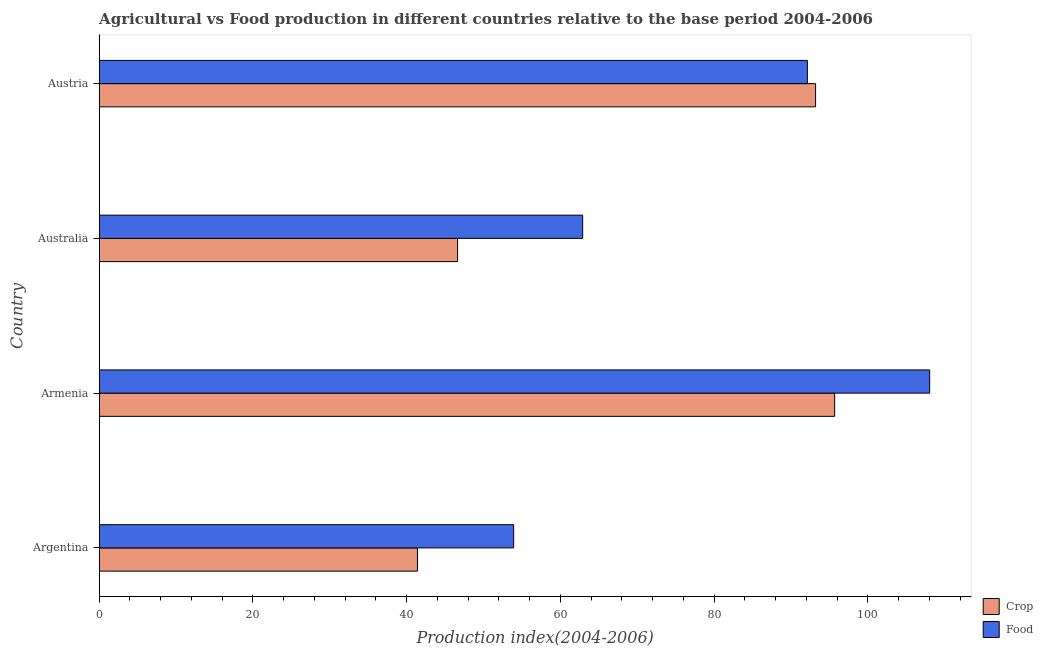How many different coloured bars are there?
Make the answer very short. 2. How many groups of bars are there?
Your answer should be compact. 4. Are the number of bars on each tick of the Y-axis equal?
Your response must be concise. Yes. How many bars are there on the 4th tick from the top?
Give a very brief answer. 2. How many bars are there on the 4th tick from the bottom?
Your answer should be compact. 2. What is the label of the 4th group of bars from the top?
Provide a short and direct response. Argentina. What is the food production index in Argentina?
Your answer should be very brief. 53.91. Across all countries, what is the maximum food production index?
Ensure brevity in your answer.  108.03. Across all countries, what is the minimum food production index?
Your response must be concise. 53.91. In which country was the food production index maximum?
Keep it short and to the point. Armenia. In which country was the crop production index minimum?
Your answer should be very brief. Argentina. What is the total crop production index in the graph?
Offer a terse response. 276.88. What is the difference between the crop production index in Australia and that in Austria?
Give a very brief answer. -46.57. What is the difference between the food production index in Australia and the crop production index in Austria?
Provide a succinct answer. -30.3. What is the average food production index per country?
Offer a terse response. 79.24. What is the difference between the crop production index and food production index in Argentina?
Offer a terse response. -12.51. In how many countries, is the food production index greater than 4 ?
Give a very brief answer. 4. Is the food production index in Armenia less than that in Austria?
Your answer should be compact. No. What is the difference between the highest and the second highest crop production index?
Provide a short and direct response. 2.48. What is the difference between the highest and the lowest food production index?
Provide a succinct answer. 54.12. Is the sum of the crop production index in Armenia and Australia greater than the maximum food production index across all countries?
Your response must be concise. Yes. What does the 2nd bar from the top in Armenia represents?
Provide a short and direct response. Crop. What does the 1st bar from the bottom in Australia represents?
Ensure brevity in your answer.  Crop. Are all the bars in the graph horizontal?
Your answer should be very brief. Yes. How many countries are there in the graph?
Provide a short and direct response. 4. What is the difference between two consecutive major ticks on the X-axis?
Make the answer very short. 20. Where does the legend appear in the graph?
Offer a terse response. Bottom right. How many legend labels are there?
Give a very brief answer. 2. What is the title of the graph?
Give a very brief answer. Agricultural vs Food production in different countries relative to the base period 2004-2006. Does "Unregistered firms" appear as one of the legend labels in the graph?
Offer a terse response. No. What is the label or title of the X-axis?
Make the answer very short. Production index(2004-2006). What is the label or title of the Y-axis?
Provide a short and direct response. Country. What is the Production index(2004-2006) of Crop in Argentina?
Make the answer very short. 41.4. What is the Production index(2004-2006) of Food in Argentina?
Ensure brevity in your answer.  53.91. What is the Production index(2004-2006) in Crop in Armenia?
Keep it short and to the point. 95.67. What is the Production index(2004-2006) in Food in Armenia?
Offer a terse response. 108.03. What is the Production index(2004-2006) of Crop in Australia?
Offer a very short reply. 46.62. What is the Production index(2004-2006) of Food in Australia?
Provide a short and direct response. 62.89. What is the Production index(2004-2006) in Crop in Austria?
Your response must be concise. 93.19. What is the Production index(2004-2006) in Food in Austria?
Provide a short and direct response. 92.12. Across all countries, what is the maximum Production index(2004-2006) of Crop?
Make the answer very short. 95.67. Across all countries, what is the maximum Production index(2004-2006) in Food?
Give a very brief answer. 108.03. Across all countries, what is the minimum Production index(2004-2006) of Crop?
Your response must be concise. 41.4. Across all countries, what is the minimum Production index(2004-2006) in Food?
Make the answer very short. 53.91. What is the total Production index(2004-2006) of Crop in the graph?
Give a very brief answer. 276.88. What is the total Production index(2004-2006) of Food in the graph?
Offer a terse response. 316.95. What is the difference between the Production index(2004-2006) of Crop in Argentina and that in Armenia?
Offer a terse response. -54.27. What is the difference between the Production index(2004-2006) of Food in Argentina and that in Armenia?
Provide a short and direct response. -54.12. What is the difference between the Production index(2004-2006) of Crop in Argentina and that in Australia?
Ensure brevity in your answer.  -5.22. What is the difference between the Production index(2004-2006) of Food in Argentina and that in Australia?
Provide a short and direct response. -8.98. What is the difference between the Production index(2004-2006) in Crop in Argentina and that in Austria?
Provide a succinct answer. -51.79. What is the difference between the Production index(2004-2006) of Food in Argentina and that in Austria?
Provide a succinct answer. -38.21. What is the difference between the Production index(2004-2006) of Crop in Armenia and that in Australia?
Offer a terse response. 49.05. What is the difference between the Production index(2004-2006) in Food in Armenia and that in Australia?
Your answer should be very brief. 45.14. What is the difference between the Production index(2004-2006) of Crop in Armenia and that in Austria?
Provide a short and direct response. 2.48. What is the difference between the Production index(2004-2006) of Food in Armenia and that in Austria?
Provide a succinct answer. 15.91. What is the difference between the Production index(2004-2006) in Crop in Australia and that in Austria?
Offer a very short reply. -46.57. What is the difference between the Production index(2004-2006) in Food in Australia and that in Austria?
Ensure brevity in your answer.  -29.23. What is the difference between the Production index(2004-2006) in Crop in Argentina and the Production index(2004-2006) in Food in Armenia?
Offer a terse response. -66.63. What is the difference between the Production index(2004-2006) of Crop in Argentina and the Production index(2004-2006) of Food in Australia?
Keep it short and to the point. -21.49. What is the difference between the Production index(2004-2006) in Crop in Argentina and the Production index(2004-2006) in Food in Austria?
Offer a very short reply. -50.72. What is the difference between the Production index(2004-2006) in Crop in Armenia and the Production index(2004-2006) in Food in Australia?
Your answer should be compact. 32.78. What is the difference between the Production index(2004-2006) of Crop in Armenia and the Production index(2004-2006) of Food in Austria?
Keep it short and to the point. 3.55. What is the difference between the Production index(2004-2006) in Crop in Australia and the Production index(2004-2006) in Food in Austria?
Your response must be concise. -45.5. What is the average Production index(2004-2006) of Crop per country?
Provide a succinct answer. 69.22. What is the average Production index(2004-2006) of Food per country?
Offer a very short reply. 79.24. What is the difference between the Production index(2004-2006) of Crop and Production index(2004-2006) of Food in Argentina?
Provide a succinct answer. -12.51. What is the difference between the Production index(2004-2006) of Crop and Production index(2004-2006) of Food in Armenia?
Your answer should be very brief. -12.36. What is the difference between the Production index(2004-2006) of Crop and Production index(2004-2006) of Food in Australia?
Your response must be concise. -16.27. What is the difference between the Production index(2004-2006) in Crop and Production index(2004-2006) in Food in Austria?
Your answer should be compact. 1.07. What is the ratio of the Production index(2004-2006) in Crop in Argentina to that in Armenia?
Your answer should be compact. 0.43. What is the ratio of the Production index(2004-2006) of Food in Argentina to that in Armenia?
Provide a short and direct response. 0.5. What is the ratio of the Production index(2004-2006) of Crop in Argentina to that in Australia?
Make the answer very short. 0.89. What is the ratio of the Production index(2004-2006) in Food in Argentina to that in Australia?
Your answer should be compact. 0.86. What is the ratio of the Production index(2004-2006) of Crop in Argentina to that in Austria?
Provide a succinct answer. 0.44. What is the ratio of the Production index(2004-2006) in Food in Argentina to that in Austria?
Give a very brief answer. 0.59. What is the ratio of the Production index(2004-2006) of Crop in Armenia to that in Australia?
Provide a succinct answer. 2.05. What is the ratio of the Production index(2004-2006) of Food in Armenia to that in Australia?
Offer a terse response. 1.72. What is the ratio of the Production index(2004-2006) of Crop in Armenia to that in Austria?
Offer a very short reply. 1.03. What is the ratio of the Production index(2004-2006) in Food in Armenia to that in Austria?
Provide a succinct answer. 1.17. What is the ratio of the Production index(2004-2006) in Crop in Australia to that in Austria?
Ensure brevity in your answer.  0.5. What is the ratio of the Production index(2004-2006) in Food in Australia to that in Austria?
Provide a short and direct response. 0.68. What is the difference between the highest and the second highest Production index(2004-2006) in Crop?
Provide a short and direct response. 2.48. What is the difference between the highest and the second highest Production index(2004-2006) in Food?
Offer a very short reply. 15.91. What is the difference between the highest and the lowest Production index(2004-2006) of Crop?
Make the answer very short. 54.27. What is the difference between the highest and the lowest Production index(2004-2006) in Food?
Your answer should be very brief. 54.12. 